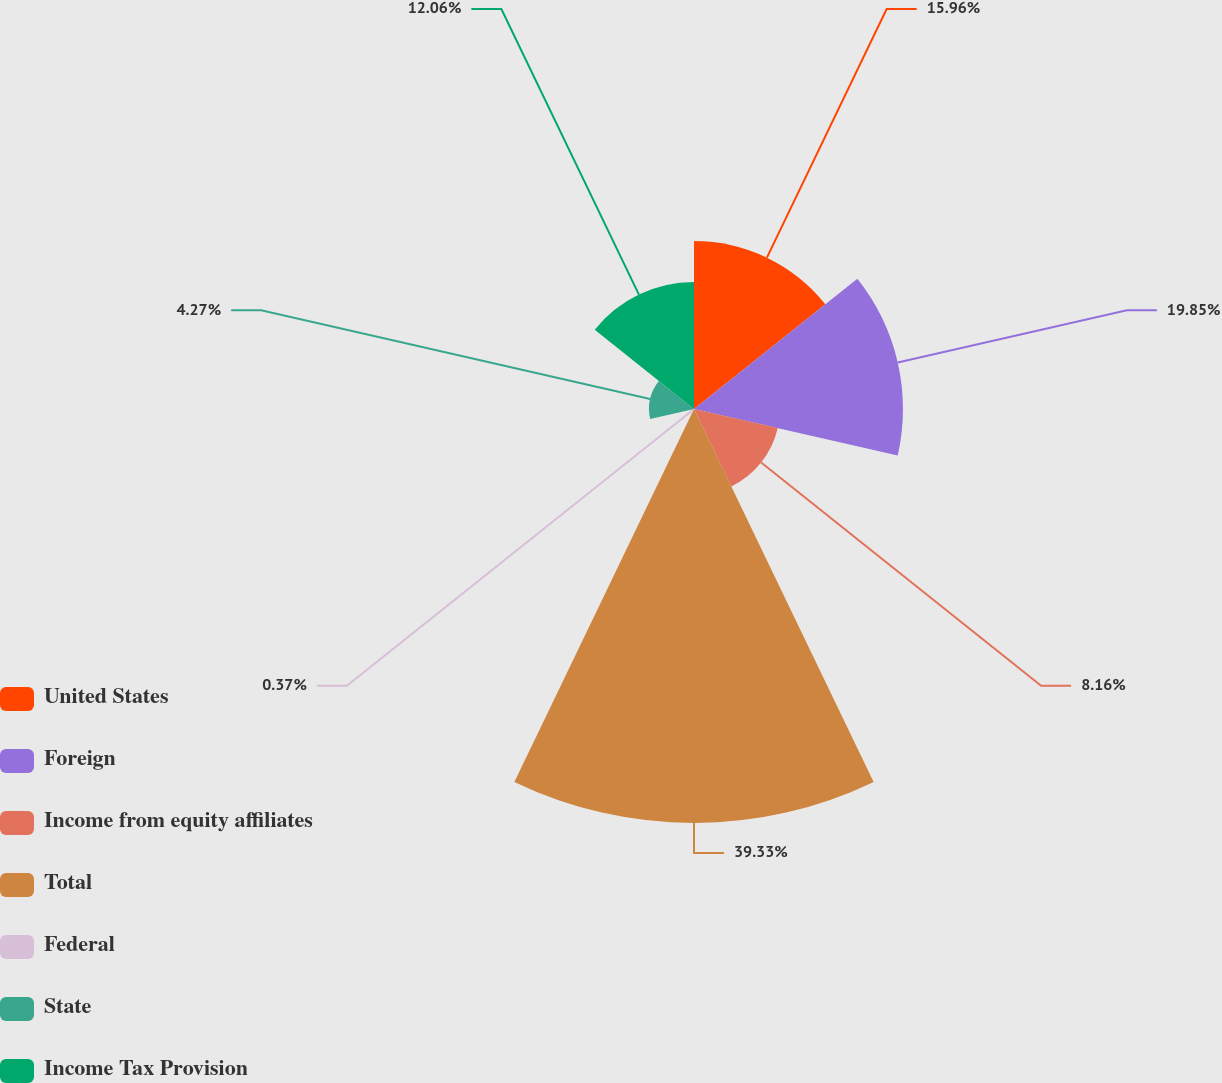Convert chart. <chart><loc_0><loc_0><loc_500><loc_500><pie_chart><fcel>United States<fcel>Foreign<fcel>Income from equity affiliates<fcel>Total<fcel>Federal<fcel>State<fcel>Income Tax Provision<nl><fcel>15.96%<fcel>19.85%<fcel>8.16%<fcel>39.33%<fcel>0.37%<fcel>4.27%<fcel>12.06%<nl></chart> 